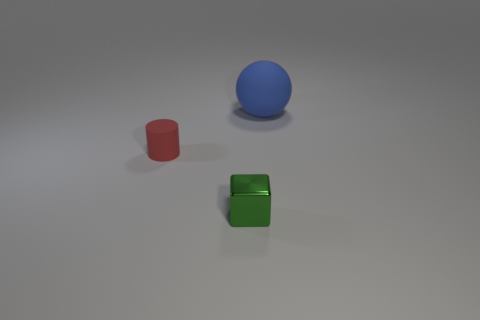Is there a yellow shiny block?
Your answer should be very brief. No. What color is the rubber object that is on the left side of the rubber ball?
Make the answer very short. Red. There is a red cylinder; does it have the same size as the thing behind the red cylinder?
Keep it short and to the point. No. There is a object that is both on the right side of the small red rubber cylinder and behind the green thing; what size is it?
Provide a succinct answer. Large. Is there a small red cylinder made of the same material as the large object?
Provide a short and direct response. Yes. There is a large blue thing; what shape is it?
Give a very brief answer. Sphere. Is the size of the ball the same as the shiny cube?
Your answer should be very brief. No. How many other objects are the same shape as the small matte object?
Make the answer very short. 0. What shape is the rubber object left of the large blue thing?
Keep it short and to the point. Cylinder. There is a matte object on the left side of the large matte object; is its shape the same as the tiny object that is in front of the small red cylinder?
Provide a short and direct response. No. 